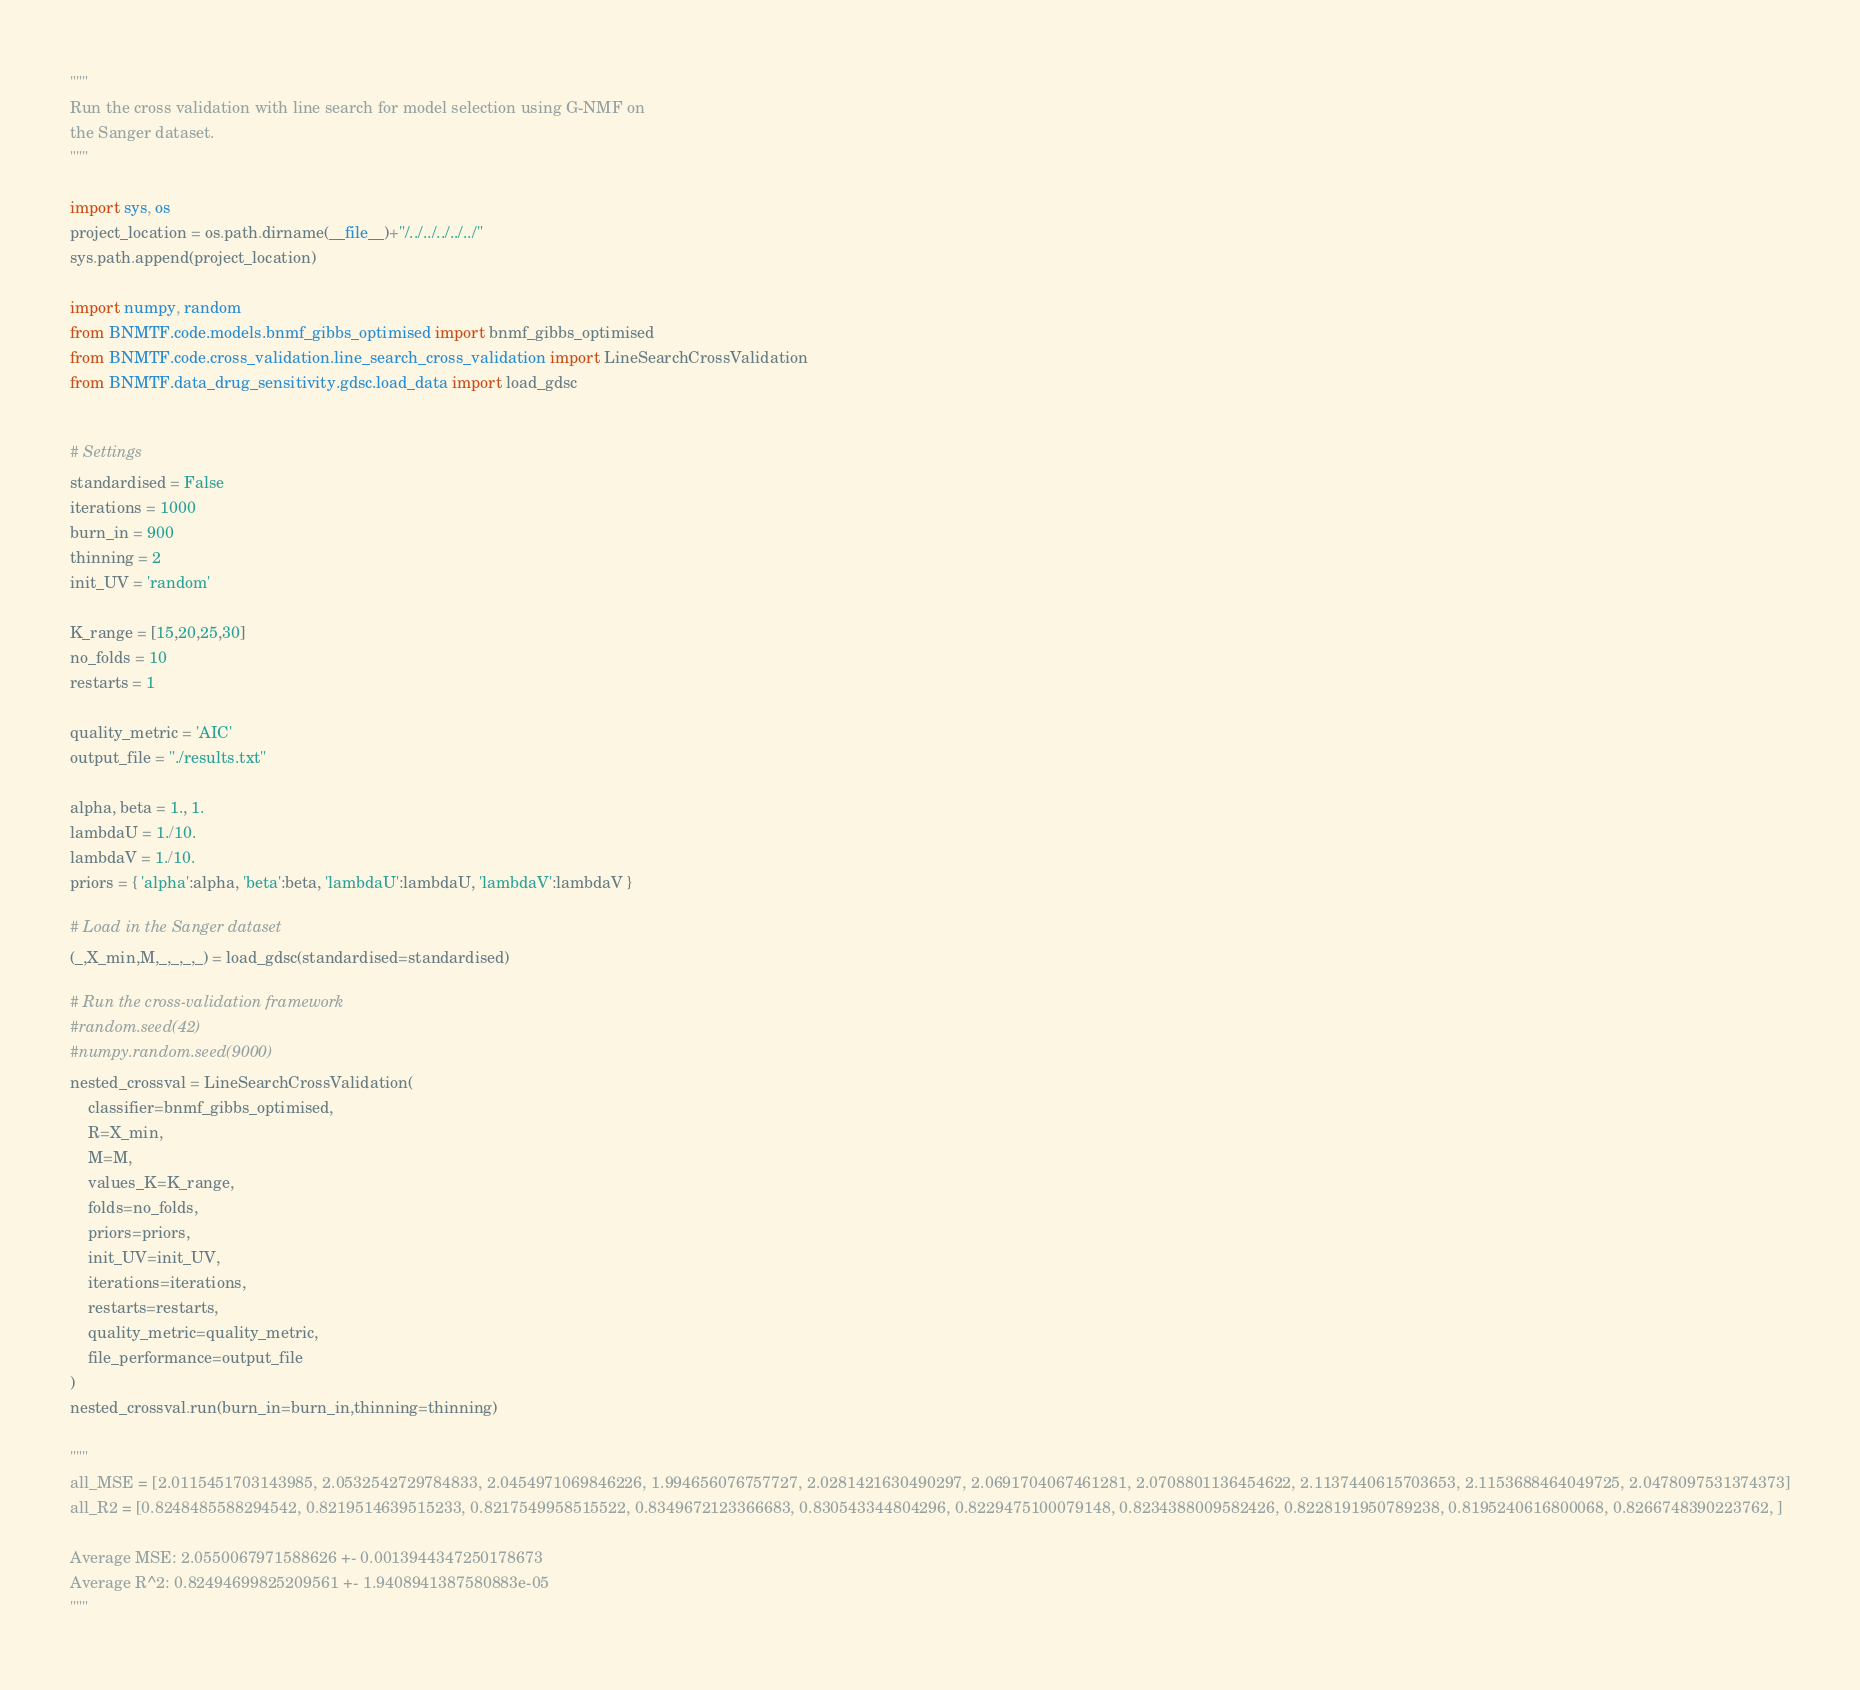<code> <loc_0><loc_0><loc_500><loc_500><_Python_>"""
Run the cross validation with line search for model selection using G-NMF on
the Sanger dataset.
"""

import sys, os
project_location = os.path.dirname(__file__)+"/../../../../../"
sys.path.append(project_location)

import numpy, random
from BNMTF.code.models.bnmf_gibbs_optimised import bnmf_gibbs_optimised
from BNMTF.code.cross_validation.line_search_cross_validation import LineSearchCrossValidation
from BNMTF.data_drug_sensitivity.gdsc.load_data import load_gdsc


# Settings
standardised = False
iterations = 1000
burn_in = 900
thinning = 2
init_UV = 'random'

K_range = [15,20,25,30]
no_folds = 10
restarts = 1

quality_metric = 'AIC'
output_file = "./results.txt"

alpha, beta = 1., 1.
lambdaU = 1./10.
lambdaV = 1./10.
priors = { 'alpha':alpha, 'beta':beta, 'lambdaU':lambdaU, 'lambdaV':lambdaV }

# Load in the Sanger dataset
(_,X_min,M,_,_,_,_) = load_gdsc(standardised=standardised)

# Run the cross-validation framework
#random.seed(42)
#numpy.random.seed(9000)
nested_crossval = LineSearchCrossValidation(
    classifier=bnmf_gibbs_optimised,
    R=X_min,
    M=M,
    values_K=K_range,
    folds=no_folds,
    priors=priors,
    init_UV=init_UV,
    iterations=iterations,
    restarts=restarts,
    quality_metric=quality_metric,
    file_performance=output_file
)
nested_crossval.run(burn_in=burn_in,thinning=thinning)

"""
all_MSE = [2.0115451703143985, 2.0532542729784833, 2.0454971069846226, 1.994656076757727, 2.0281421630490297, 2.0691704067461281, 2.0708801136454622, 2.1137440615703653, 2.1153688464049725, 2.0478097531374373]
all_R2 = [0.8248485588294542, 0.8219514639515233, 0.8217549958515522, 0.8349672123366683, 0.830543344804296, 0.8229475100079148, 0.8234388009582426, 0.8228191950789238, 0.8195240616800068, 0.8266748390223762, ]

Average MSE: 2.0550067971588626 +- 0.0013944347250178673
Average R^2: 0.82494699825209561 +- 1.9408941387580883e-05
"""</code> 